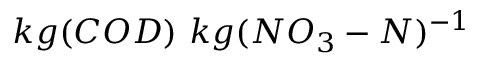Convert formula to latex. <formula><loc_0><loc_0><loc_500><loc_500>k g ( C O D ) \ k g ( N O _ { 3 } - N ) ^ { - 1 }</formula> 